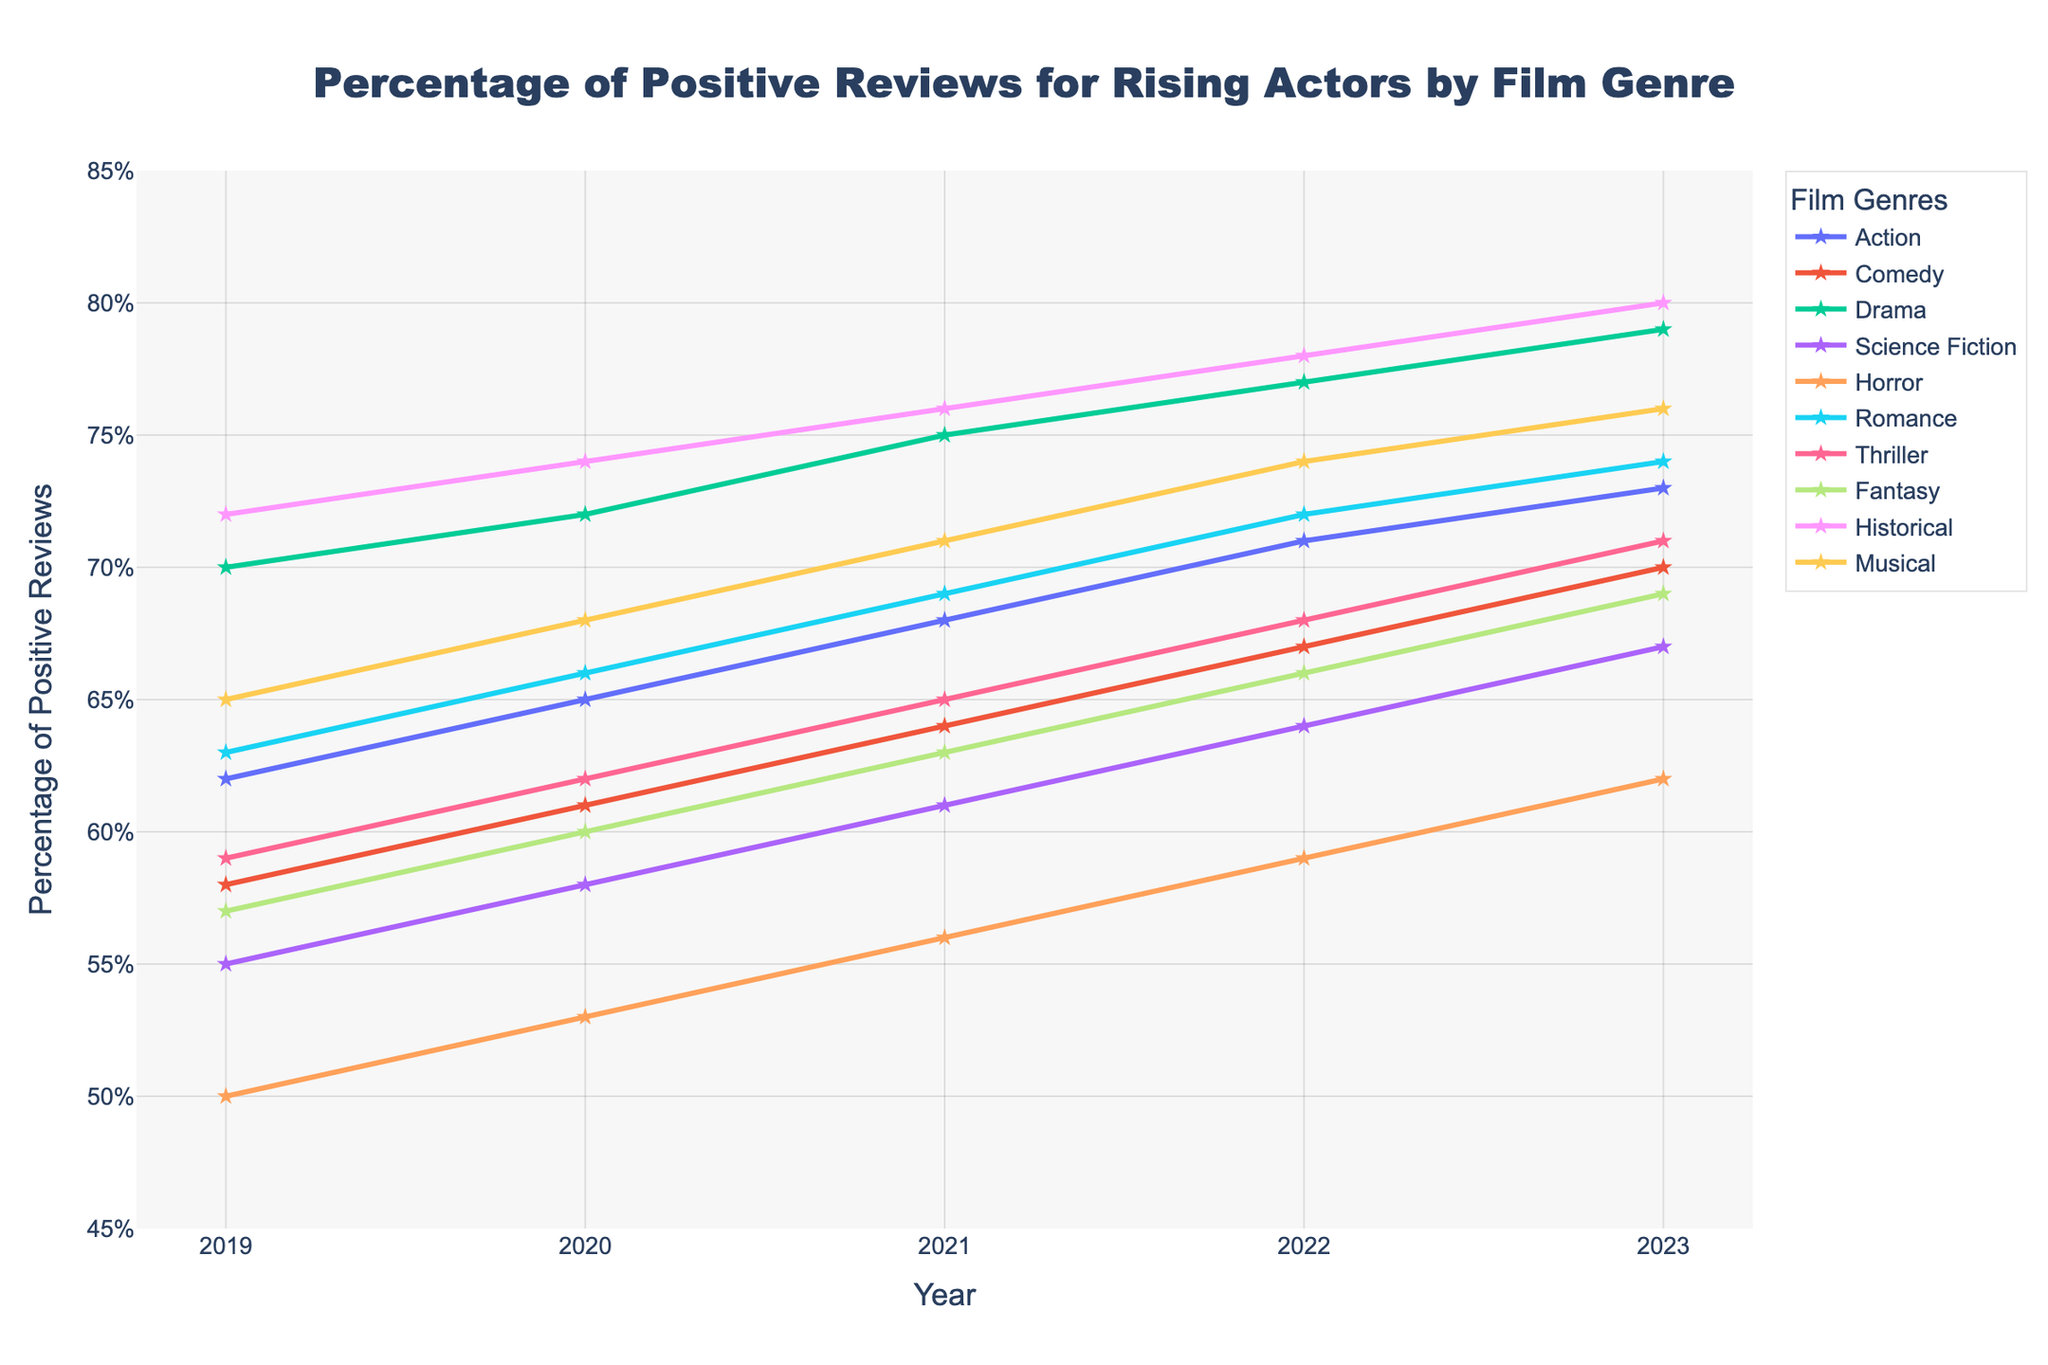what's the genre with the lowest percentage of positive reviews in 2019? In 2019, examine each genre to determine which has the lowest percentage of positive reviews. Horror has the lowest at 50%.
Answer: Horror how much did the percentage of positive reviews for Action increase from 2019 to 2023? Subtract the percentage of positive reviews for Action in 2019 from that in 2023: 73 - 62 = 11%
Answer: 11% which genres had a percentage of positive reviews above 70% in 2023? Look at the percentages for each genre in 2023. The genres above 70% are Action, Comedy, Drama, Romance, Thriller, Historical, and Musical.
Answer: Action, Comedy, Drama, Romance, Thriller, Historical, Musical compare the rate of increase in positive reviews between Science Fiction and Fantasy from 2019 to 2023. Which genre saw a greater increase? Calculate the increase for each genre from 2019 to 2023. Science Fiction increased by 67 - 55 = 12%, and Fantasy increased by 69 - 57 = 12%. Both rates are the same.
Answer: Both are equal which genre had the highest percentage increase in positive reviews over the 5 years? Compute the increase for each genre from 2019 to 2023 and find the highest. Historical increased from 72% to 80%, an increase of 8%. Upon review, Drama increased from 70% to 79%, an increase of 9%.
Answer: Drama what is the trend for the Comedy genre over the 5 years? Observe the values for Comedy: 58, 61, 64, 67, 70. The trend shows a consistent increase each year.
Answer: Increasing compare the 2020 data: which genre had the highest and which had the lowest percentage of positive reviews? Refer to the 2020 data. Historical had the highest at 74%, and Horror had the lowest at 53%.
Answer: Highest: Historical, Lowest: Horror which genre had the most consistent increase in positive reviews from 2019 to 2023? Identify the genre with a steady annual increase. Romance shows a consistent increase of 3% each year from 2019 to 2023.
Answer: Romance 